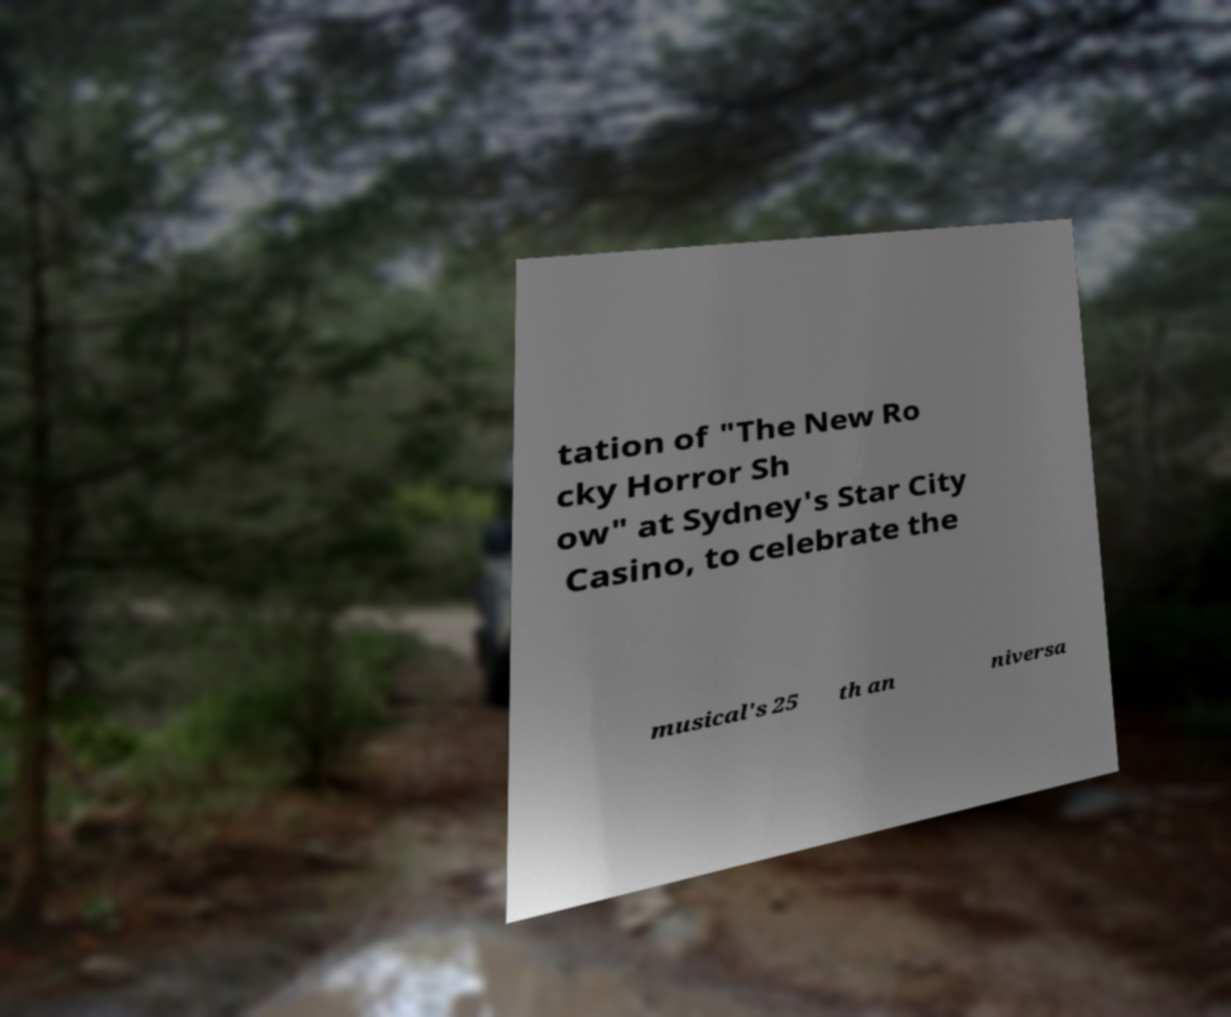Please identify and transcribe the text found in this image. tation of "The New Ro cky Horror Sh ow" at Sydney's Star City Casino, to celebrate the musical's 25 th an niversa 